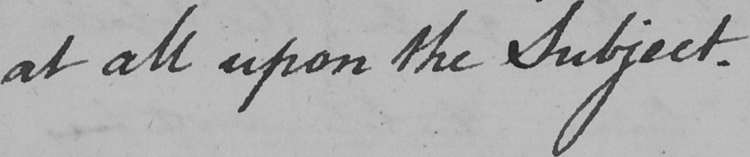Please transcribe the handwritten text in this image. at all upon the Subject . 